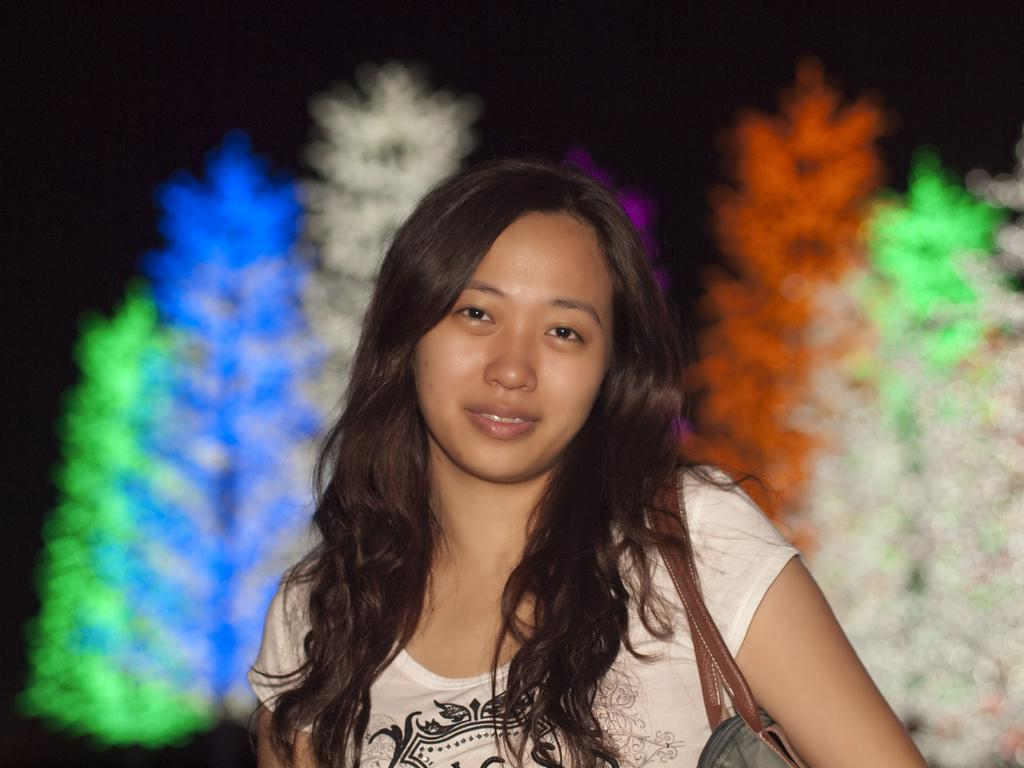Who is the main subject in the image? There is a woman in the image. What is the woman doing in the image? The woman is standing. What is the woman wearing in the image? The woman is wearing a white t-shirt. Can you describe the background of the image? The background of the image is blurry. What type of nail is the woman holding in the image? There is no nail present in the image; the woman is only wearing a white t-shirt and standing. 